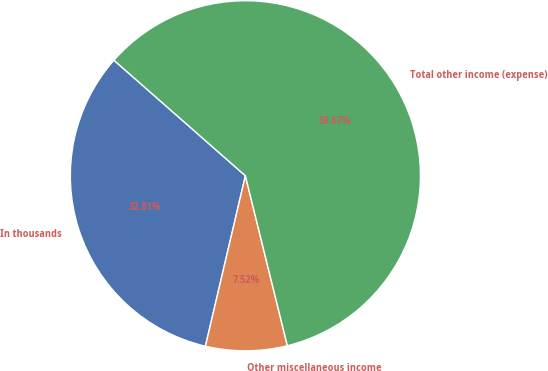Convert chart to OTSL. <chart><loc_0><loc_0><loc_500><loc_500><pie_chart><fcel>In thousands<fcel>Other miscellaneous income<fcel>Total other income (expense)<nl><fcel>32.81%<fcel>7.52%<fcel>59.67%<nl></chart> 